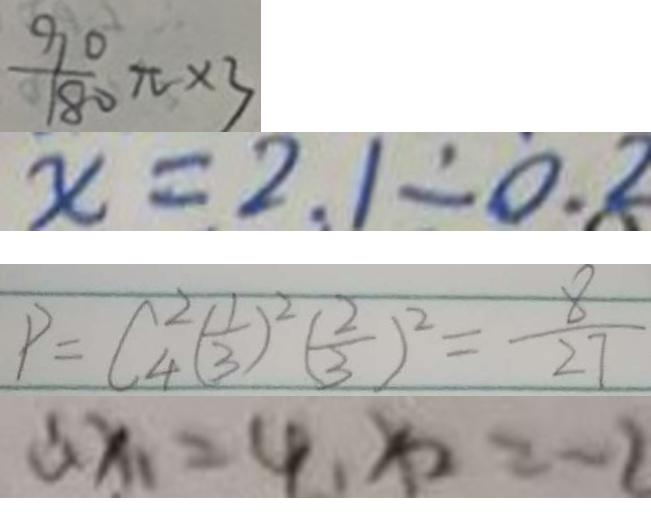Convert formula to latex. <formula><loc_0><loc_0><loc_500><loc_500>\frac { 9 0 } { 1 8 0 } \pi \times 3 
 x = 2 1 \div 0 . 8 
 P = C _ { 4 } ^ { 2 } ( \frac { 1 } { 3 } ) ^ { 2 } ( \frac { 2 } { 3 } ) ^ { 2 } = \frac { 8 } { 2 7 } 
 \therefore x _ { 1 } = 4 , x _ { 2 } = - 2</formula> 